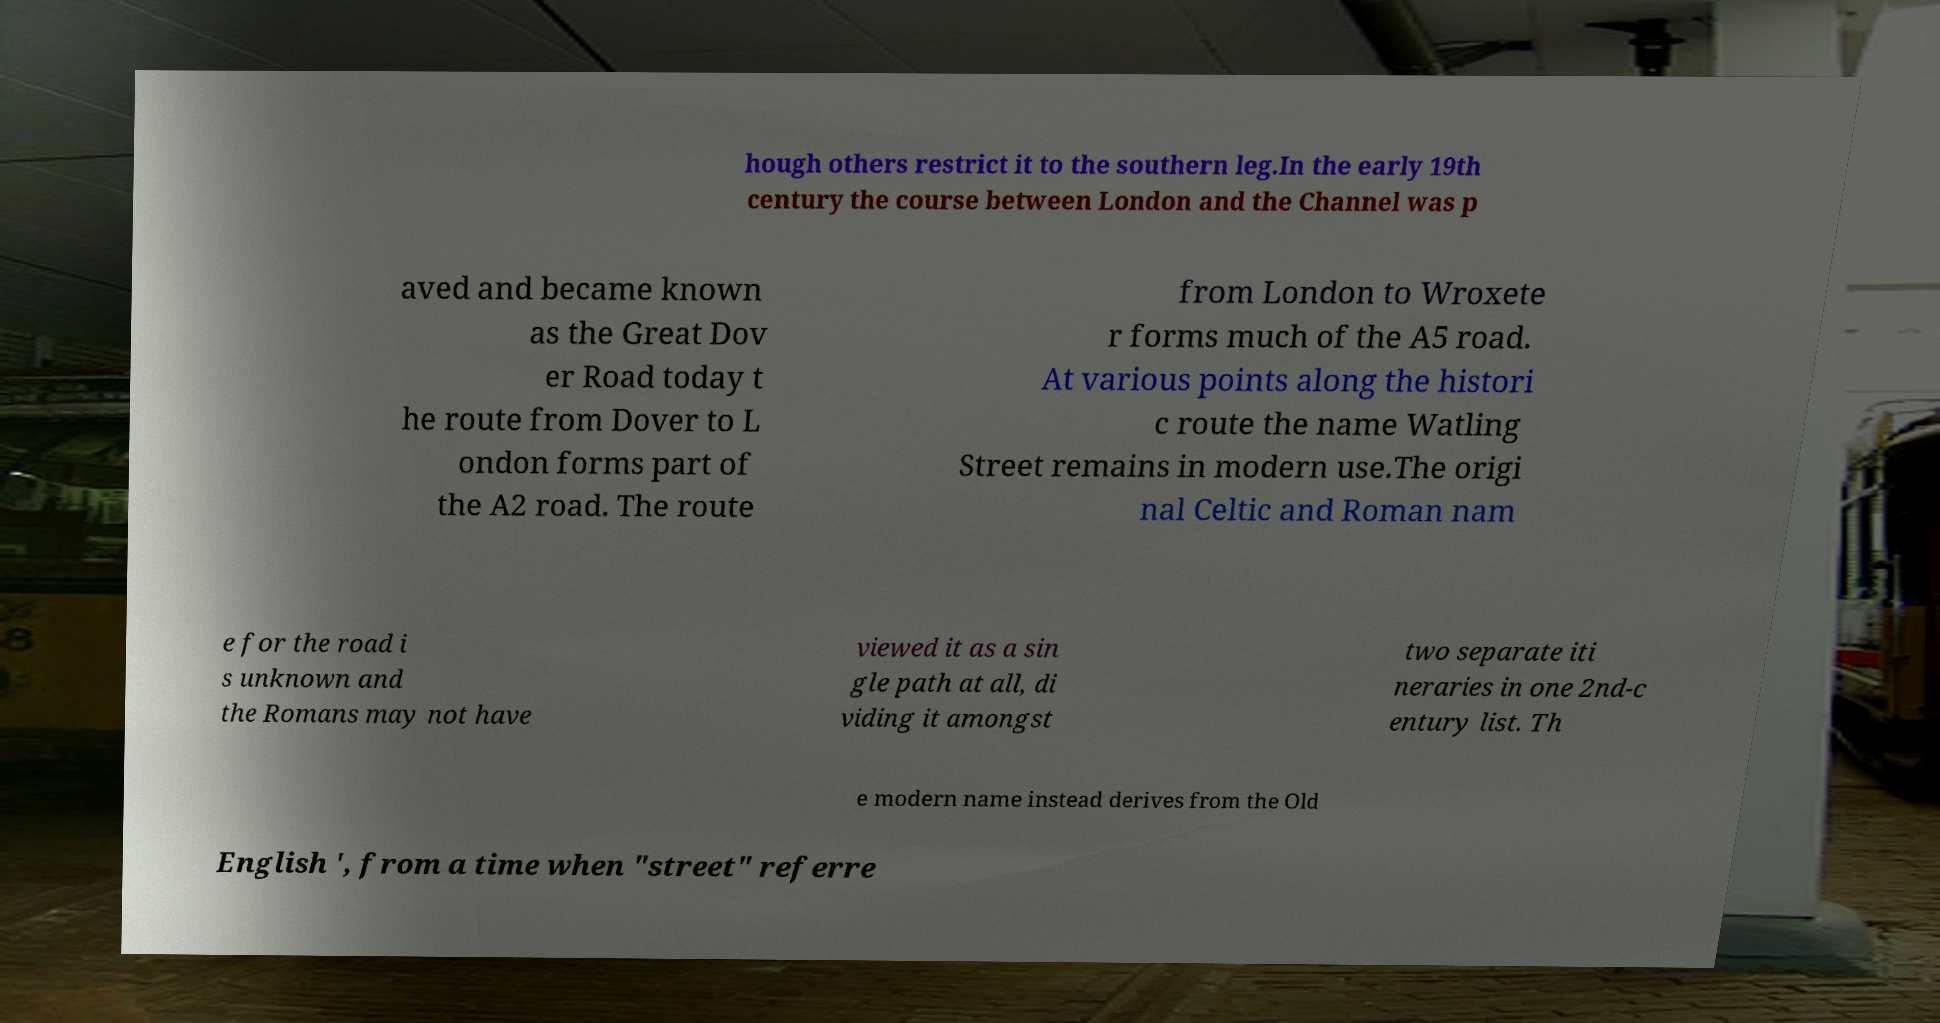For documentation purposes, I need the text within this image transcribed. Could you provide that? hough others restrict it to the southern leg.In the early 19th century the course between London and the Channel was p aved and became known as the Great Dov er Road today t he route from Dover to L ondon forms part of the A2 road. The route from London to Wroxete r forms much of the A5 road. At various points along the histori c route the name Watling Street remains in modern use.The origi nal Celtic and Roman nam e for the road i s unknown and the Romans may not have viewed it as a sin gle path at all, di viding it amongst two separate iti neraries in one 2nd-c entury list. Th e modern name instead derives from the Old English ', from a time when "street" referre 